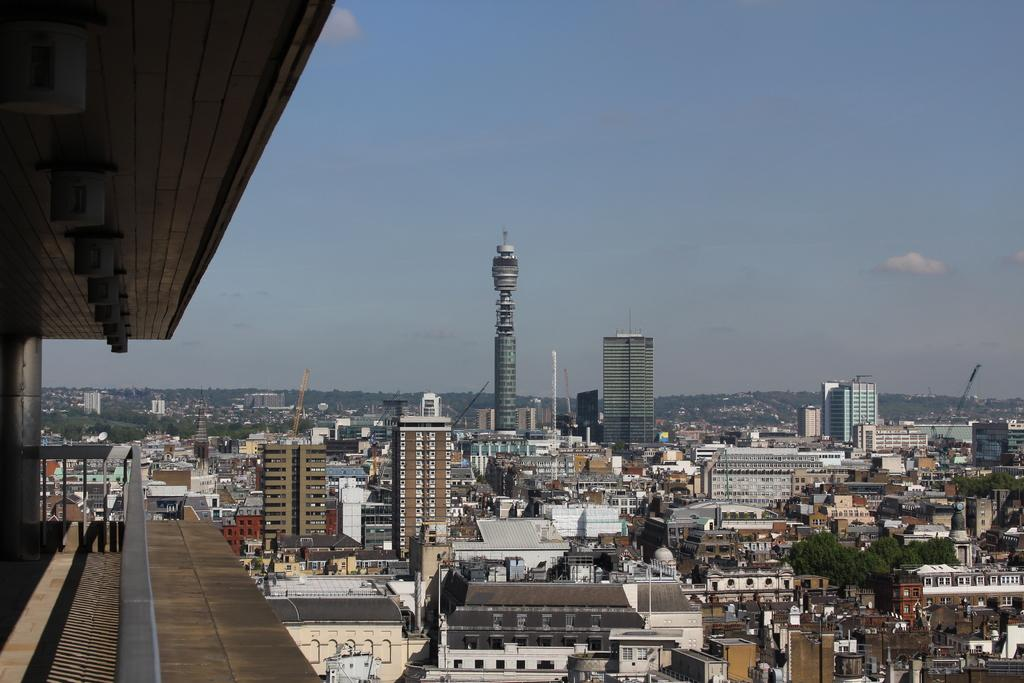What type of structures can be seen in the image? There are many buildings and towers in the image. What else can be seen in the image besides buildings and towers? There are trees and cranes visible in the image. What is visible in the background of the image? The sky is visible in the image. How does the uncle sort the buildings in the image? There is no uncle present in the image, and therefore no sorting activity can be observed. 